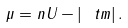Convert formula to latex. <formula><loc_0><loc_0><loc_500><loc_500>\mu = n U - | \ t m | \, .</formula> 